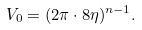Convert formula to latex. <formula><loc_0><loc_0><loc_500><loc_500>V _ { 0 } = ( 2 \pi \cdot 8 \eta ) ^ { n - 1 } .</formula> 